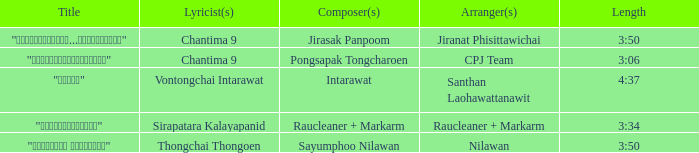Who was the composer for the track that had sirapatara kalayapanid as its lyric writer? Raucleaner + Markarm. 